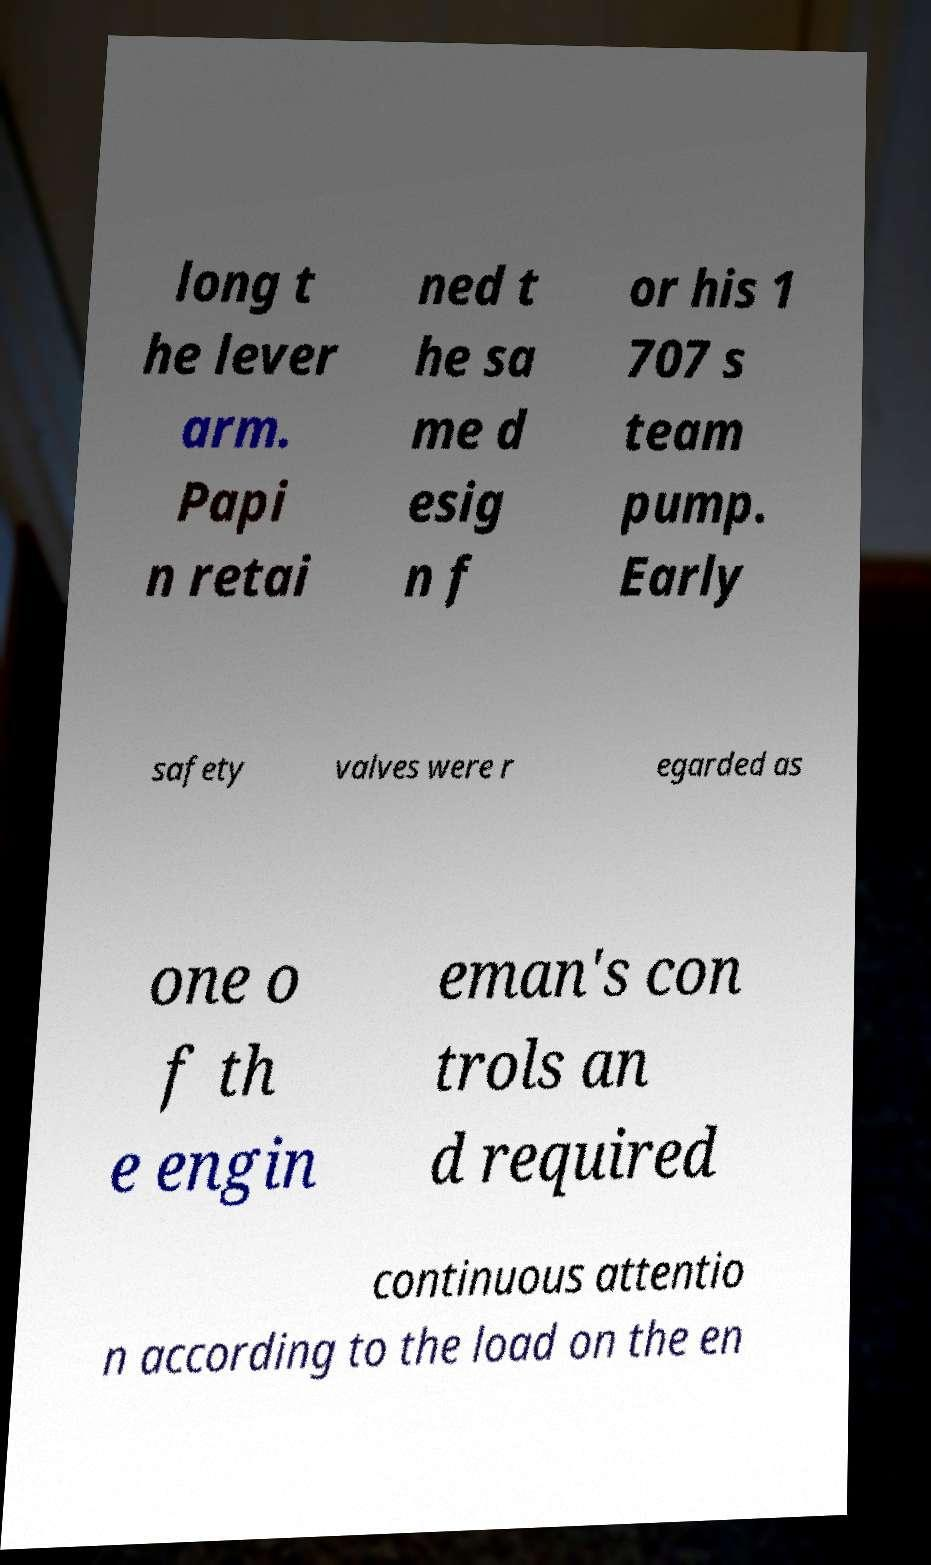Could you extract and type out the text from this image? long t he lever arm. Papi n retai ned t he sa me d esig n f or his 1 707 s team pump. Early safety valves were r egarded as one o f th e engin eman's con trols an d required continuous attentio n according to the load on the en 